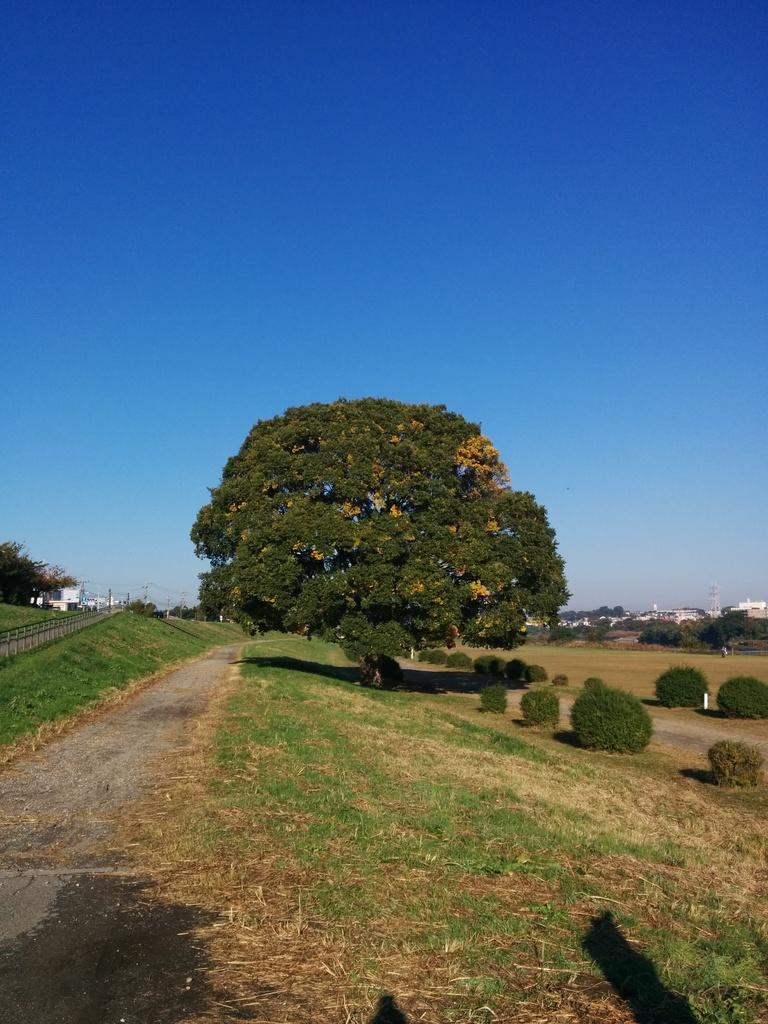What type of vegetation can be seen in the image? There are trees in the image. What is located on the left side of the image? There is a road on the left side of the image. What is visible at the top of the image? The sky is visible at the top of the image. Can you see any metal structures on the seashore in the image? There is no seashore or metal structures present in the image; it features trees, a road, and the sky. 